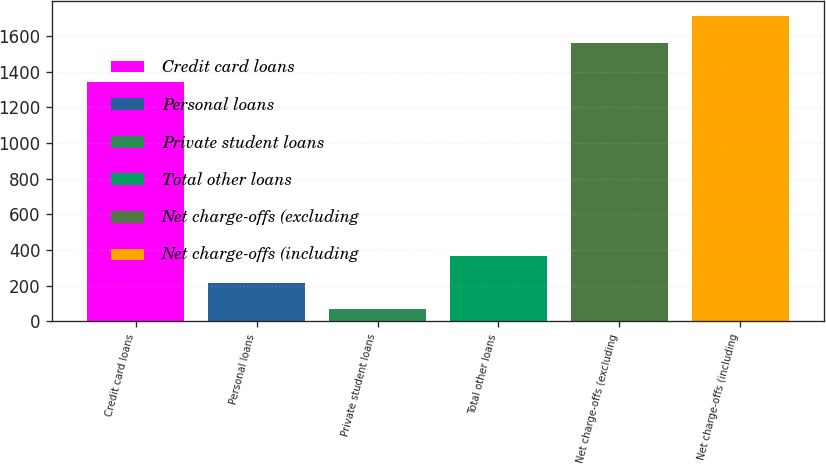Convert chart to OTSL. <chart><loc_0><loc_0><loc_500><loc_500><bar_chart><fcel>Credit card loans<fcel>Personal loans<fcel>Private student loans<fcel>Total other loans<fcel>Net charge-offs (excluding<fcel>Net charge-offs (including<nl><fcel>1343<fcel>216.4<fcel>67<fcel>365.8<fcel>1561<fcel>1710.4<nl></chart> 